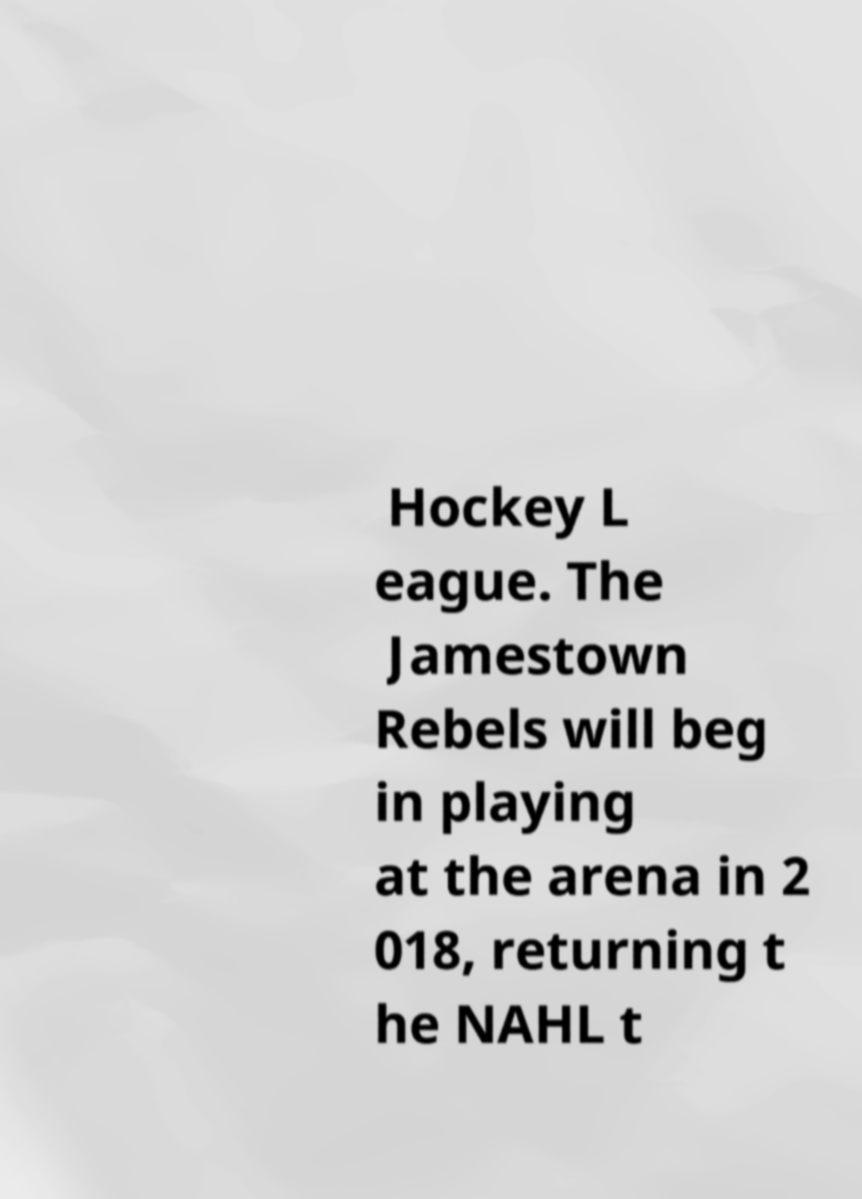Can you read and provide the text displayed in the image?This photo seems to have some interesting text. Can you extract and type it out for me? Hockey L eague. The Jamestown Rebels will beg in playing at the arena in 2 018, returning t he NAHL t 